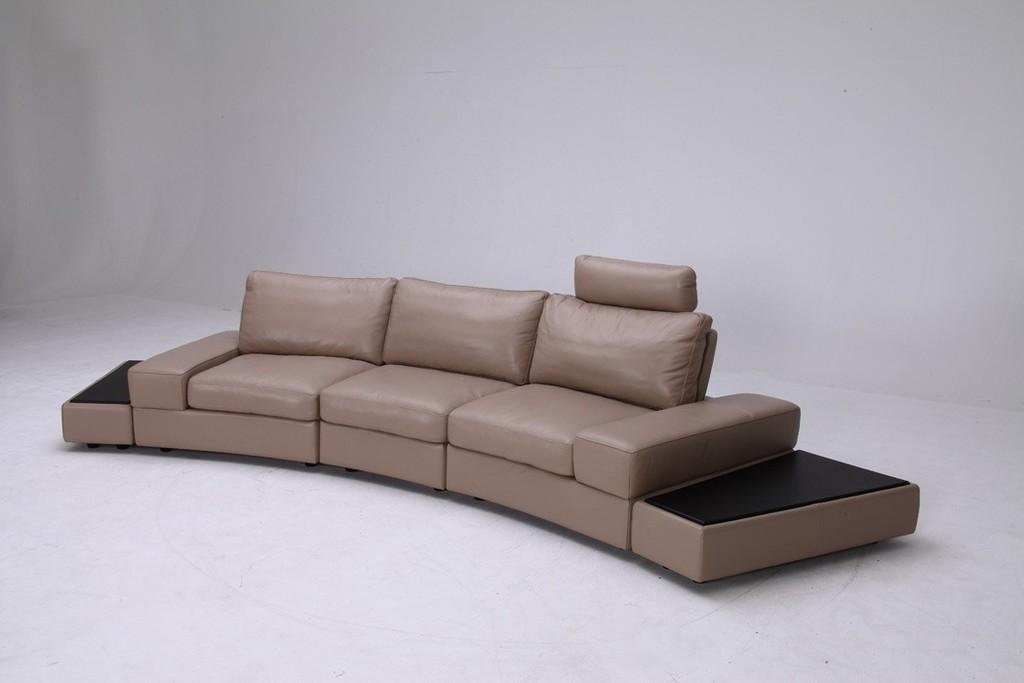Where was the image taken? The image was taken in a room. What is the main piece of furniture in the room? There is a brown sofa in the middle of the image. Can you hear the sound of a river flowing in the image? There is no river or any sound present in the image, as it is a still photograph taken in a room with a brown sofa. 